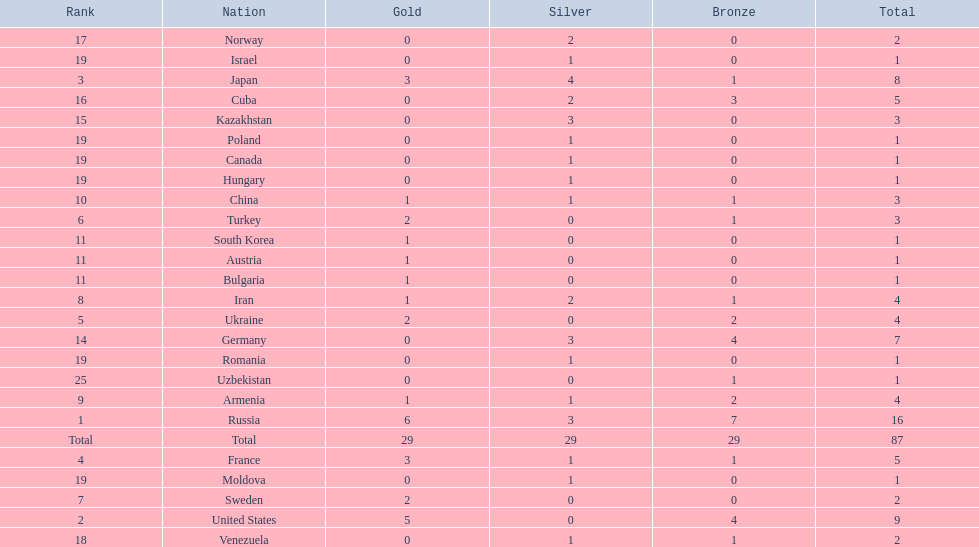What were the nations that participated in the 1995 world wrestling championships? Russia, United States, Japan, France, Ukraine, Turkey, Sweden, Iran, Armenia, China, Austria, Bulgaria, South Korea, Germany, Kazakhstan, Cuba, Norway, Venezuela, Canada, Hungary, Israel, Moldova, Poland, Romania, Uzbekistan. How many gold medals did the united states earn in the championship? 5. What amount of medals earner was greater than this value? 6. What country earned these medals? Russia. 